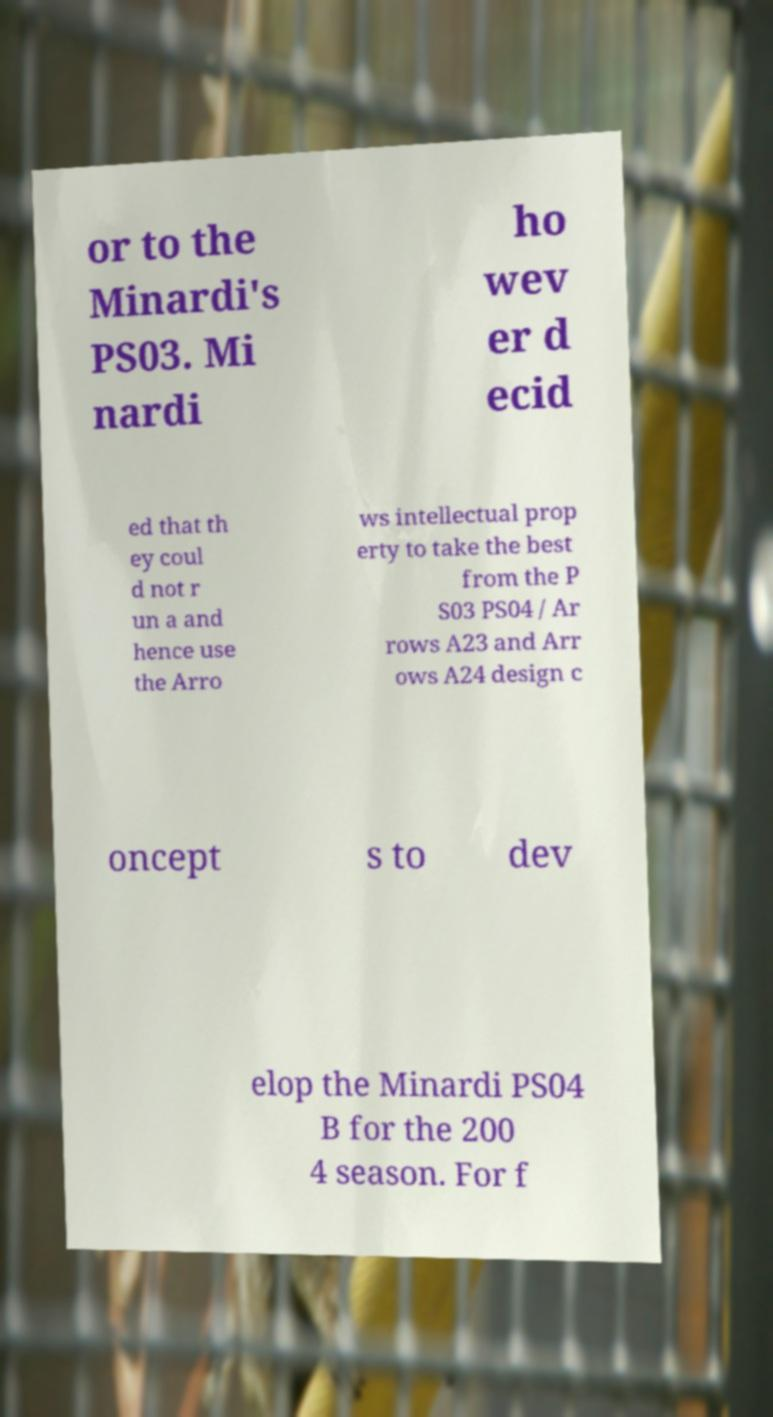Could you extract and type out the text from this image? or to the Minardi's PS03. Mi nardi ho wev er d ecid ed that th ey coul d not r un a and hence use the Arro ws intellectual prop erty to take the best from the P S03 PS04 / Ar rows A23 and Arr ows A24 design c oncept s to dev elop the Minardi PS04 B for the 200 4 season. For f 